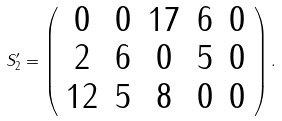<formula> <loc_0><loc_0><loc_500><loc_500>S _ { 2 } ^ { \prime } = \left ( \begin{array} { c c c c c } 0 & 0 & 1 7 & 6 & 0 \\ 2 & 6 & 0 & 5 & 0 \\ 1 2 & 5 & 8 & 0 & 0 \end{array} \right ) .</formula> 